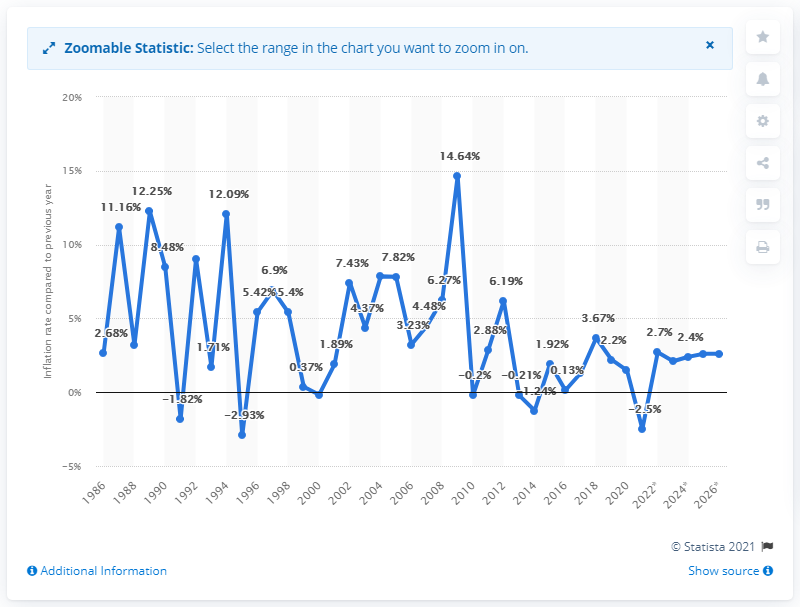Outline some significant characteristics in this image. In 2020, the inflation rate in Samoa was 1.48%. 